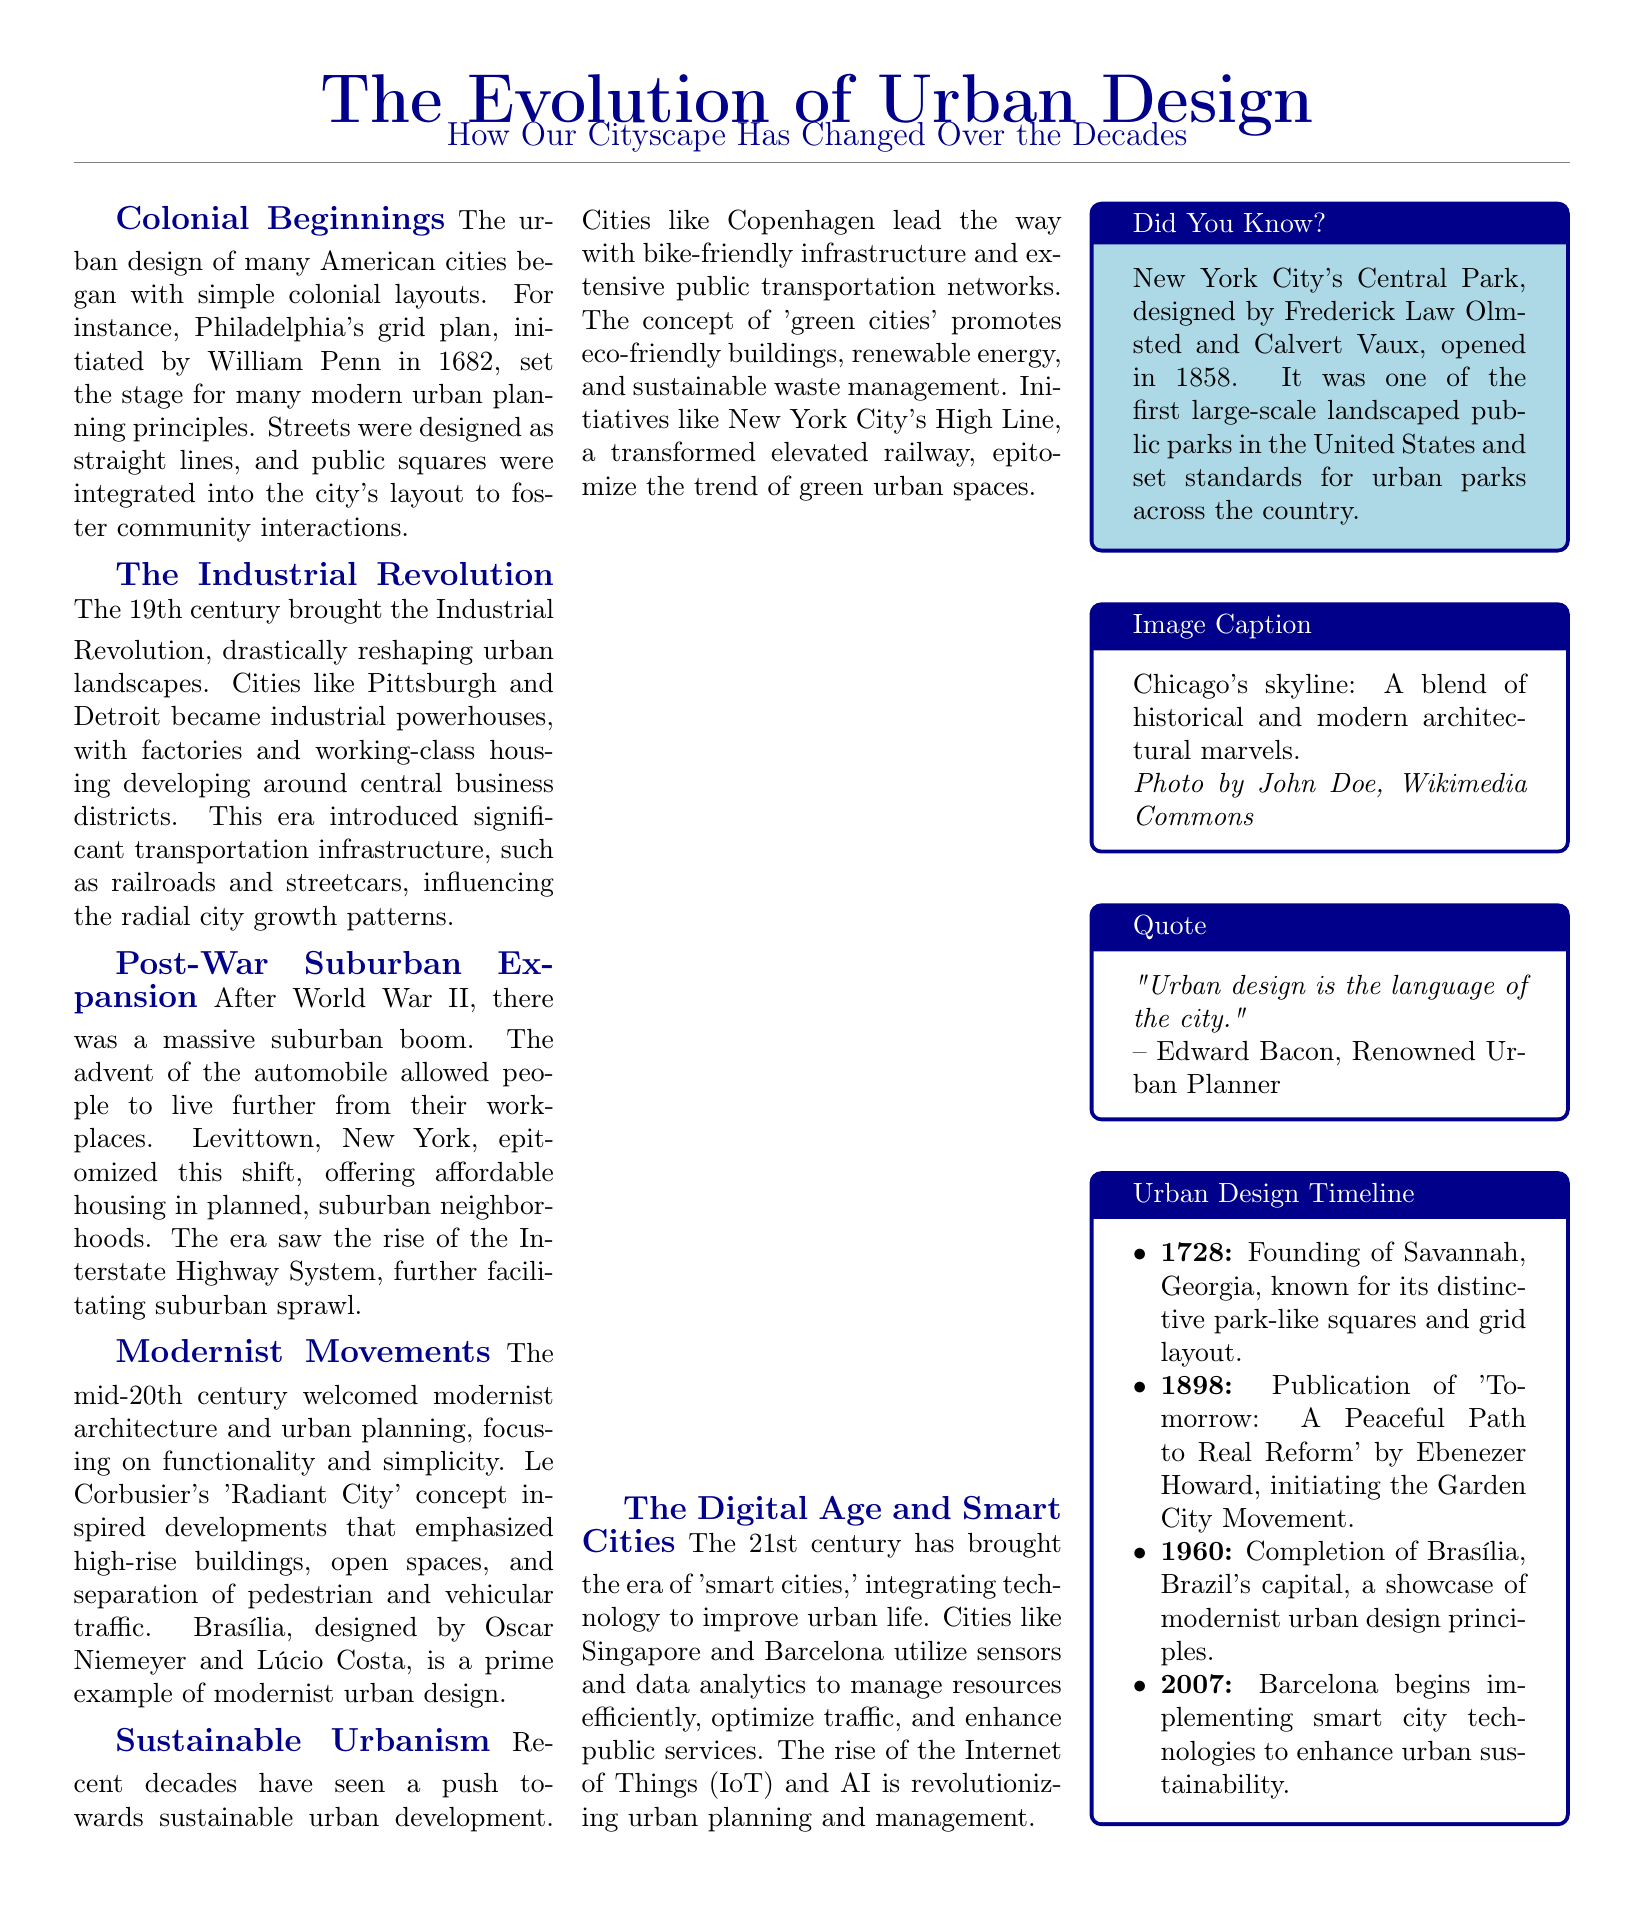What year was the grid plan for Philadelphia initiated? The document states that the grid plan for Philadelphia was initiated in 1682.
Answer: 1682 What characterized the cities during the Industrial Revolution? The document describes cities like Pittsburgh and Detroit becoming industrial powerhouses with factories and working-class housing developing around central business districts.
Answer: Industrial powerhouses What does Levittown, New York represent? The document mentions that Levittown, New York epitomized the shift to suburban living after World War II by offering affordable housing in planned neighborhoods.
Answer: Suburban boom Who inspired modernist developments? Le Corbusier's 'Radiant City' concept is noted in the document as having inspired modernist developments focused on functionality and simplicity.
Answer: Le Corbusier What is a key feature of sustainable urban development? The document highlights that cities like Copenhagen lead in bike-friendly infrastructure and extensive public transportation networks as key features of sustainable urban development.
Answer: Bike-friendly infrastructure Which city began implementing smart city technologies in 2007? According to the timeline in the document, Barcelona began implementing smart city technologies in 2007 to enhance urban sustainability.
Answer: Barcelona What was one of the first large-scale landscaped public parks in the United States? The document states that New York City's Central Park was one of the first large-scale landscaped public parks in the United States.
Answer: Central Park What is the title of the quote by Edward Bacon? The document includes a quote by Edward Bacon stating, "Urban design is the language of the city."
Answer: "Urban design is the language of the city." What distinctive feature is Savannah, Georgia known for? The document indicates that Savannah, Georgia is known for its distinctive park-like squares and grid layout, established in 1728.
Answer: Park-like squares 